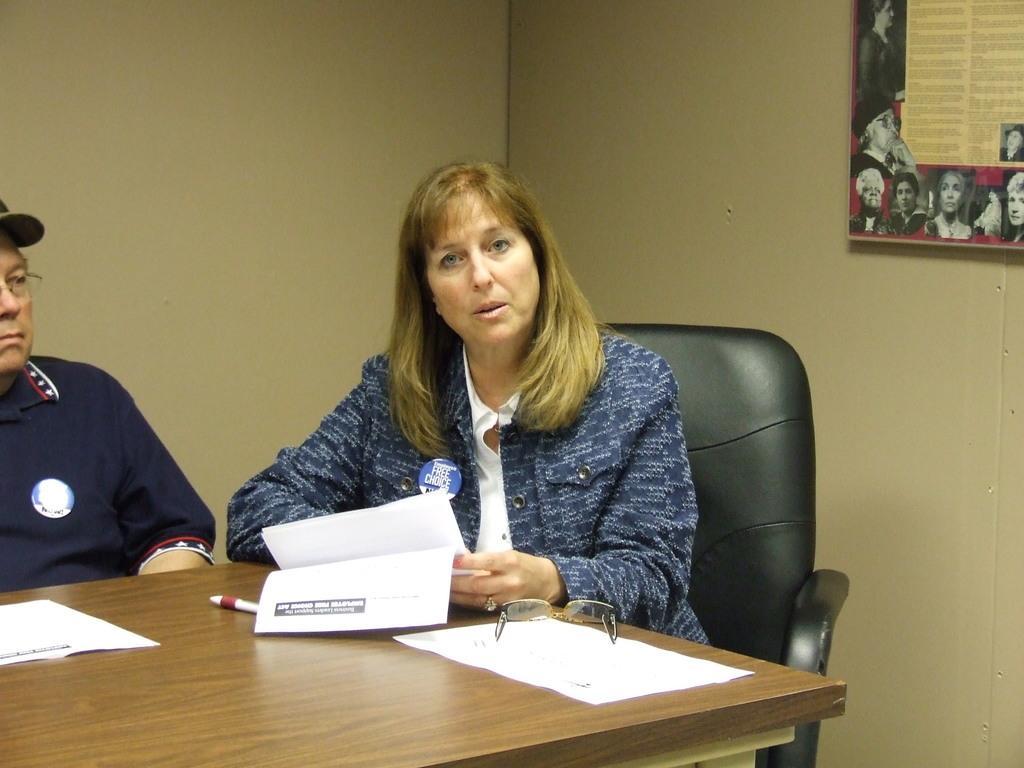Could you give a brief overview of what you see in this image? In this image a woman is sitting on chair before a table by holding papers. Spects and a pen are on table. At the right side of the image a person is sitting by wearing a cap. At the top right corner there is a poster fixed to the wall. 